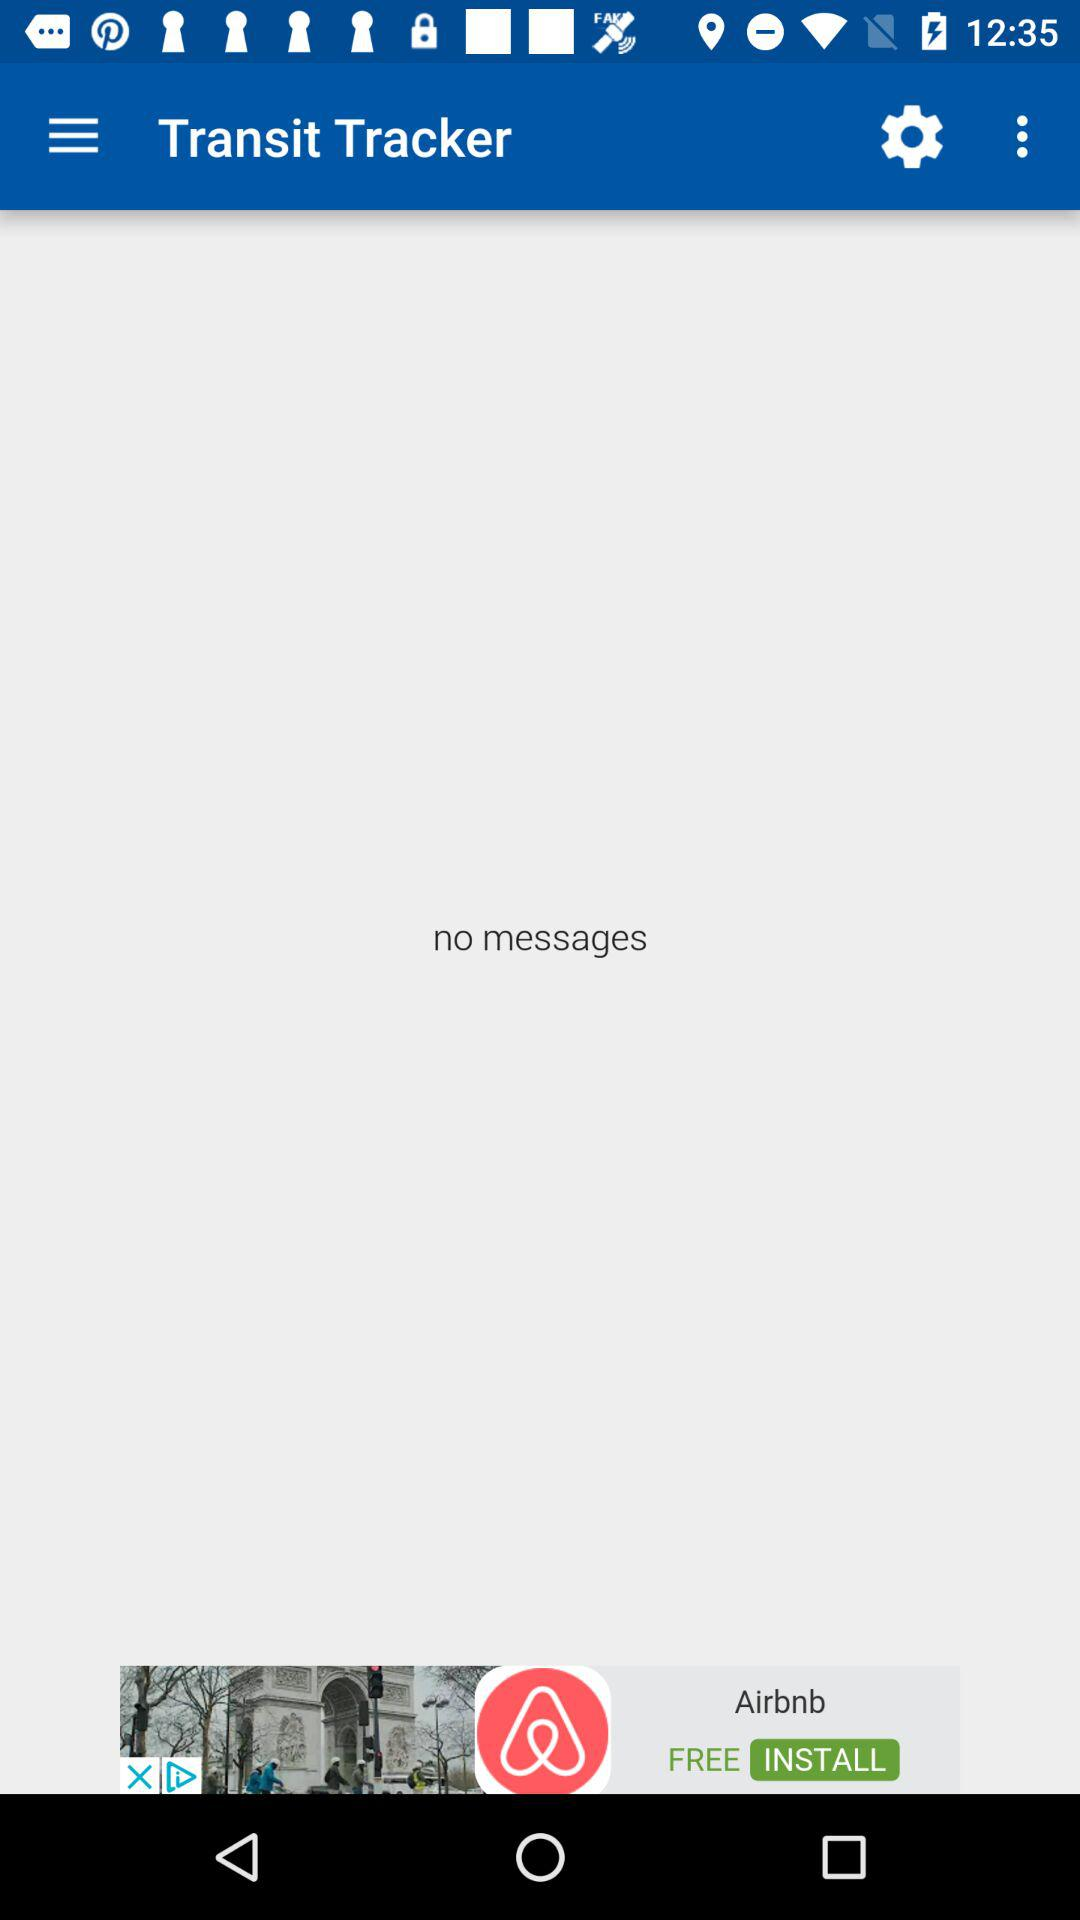What is the name of the application? The name of the application is "Transit Tracker". 